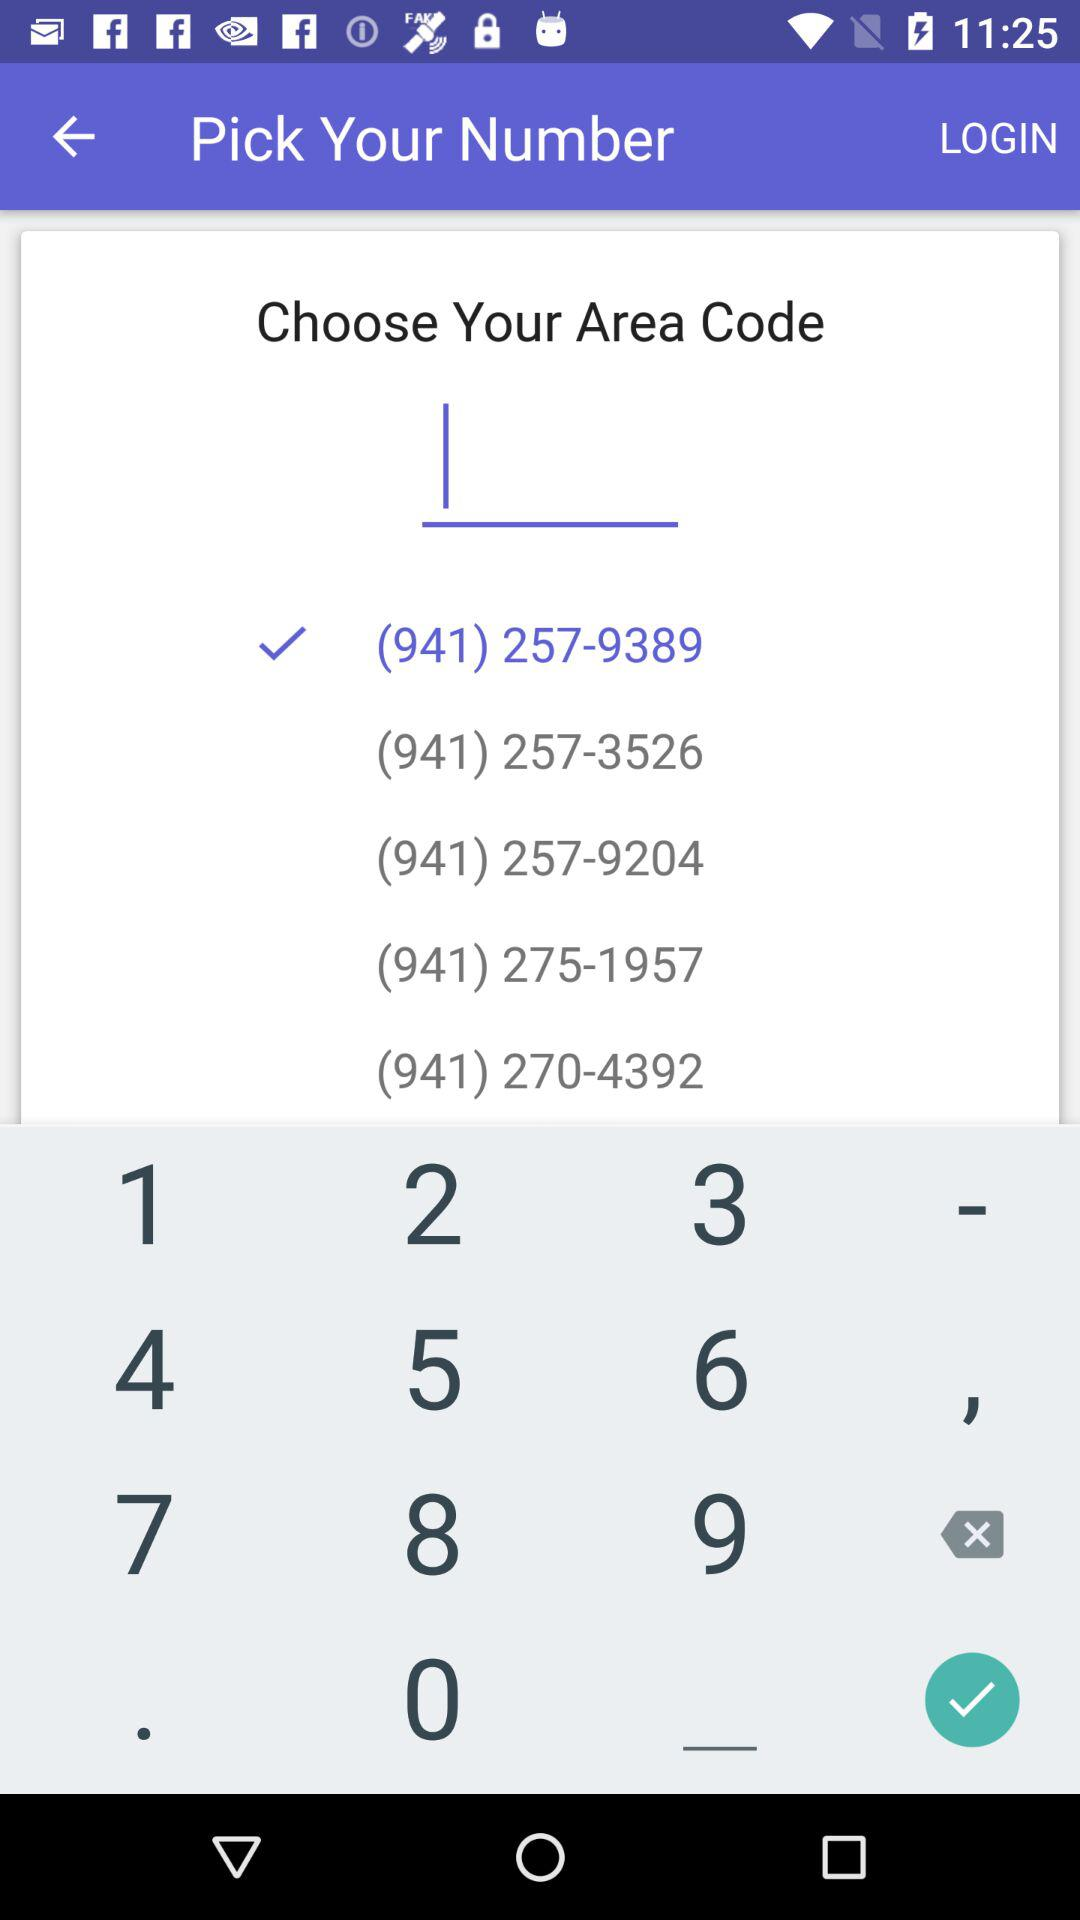Which "Area Code" is selected? The selected "Area Code" is 941. 